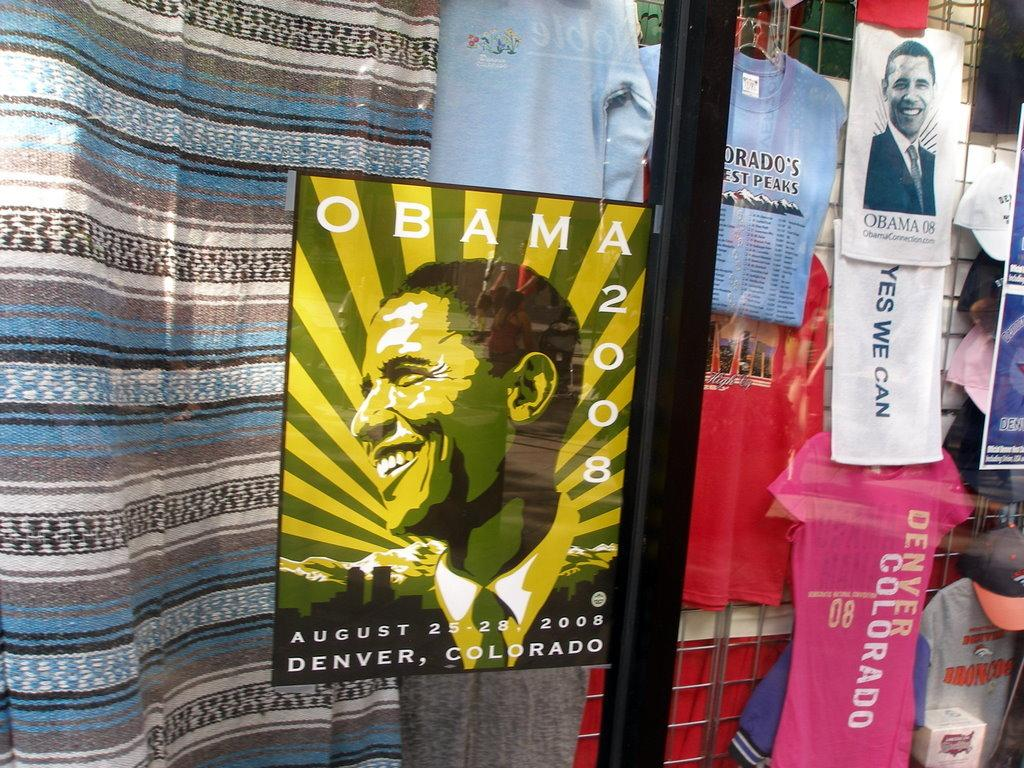<image>
Give a short and clear explanation of the subsequent image. A advertisment for Obama to be in Denver Colorado in 2008 